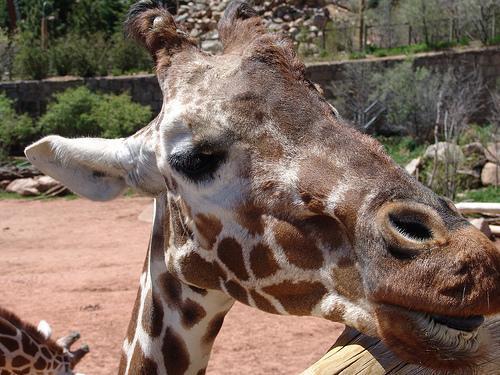How many giraffes are visible?
Give a very brief answer. 2. How many stumps are on its head?
Give a very brief answer. 2. 